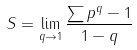Convert formula to latex. <formula><loc_0><loc_0><loc_500><loc_500>S = \lim _ { q \to 1 } \frac { \sum p ^ { q } - 1 } { 1 - q }</formula> 